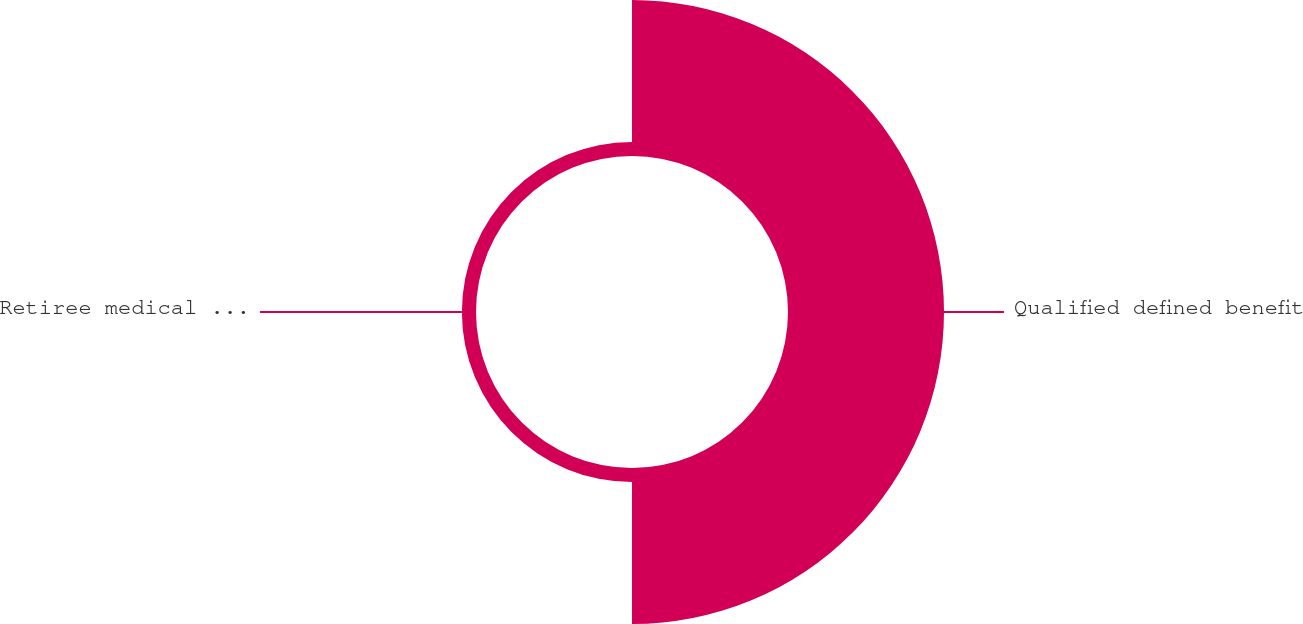Convert chart to OTSL. <chart><loc_0><loc_0><loc_500><loc_500><pie_chart><fcel>Qualified defined benefit<fcel>Retiree medical and life<nl><fcel>91.7%<fcel>8.3%<nl></chart> 